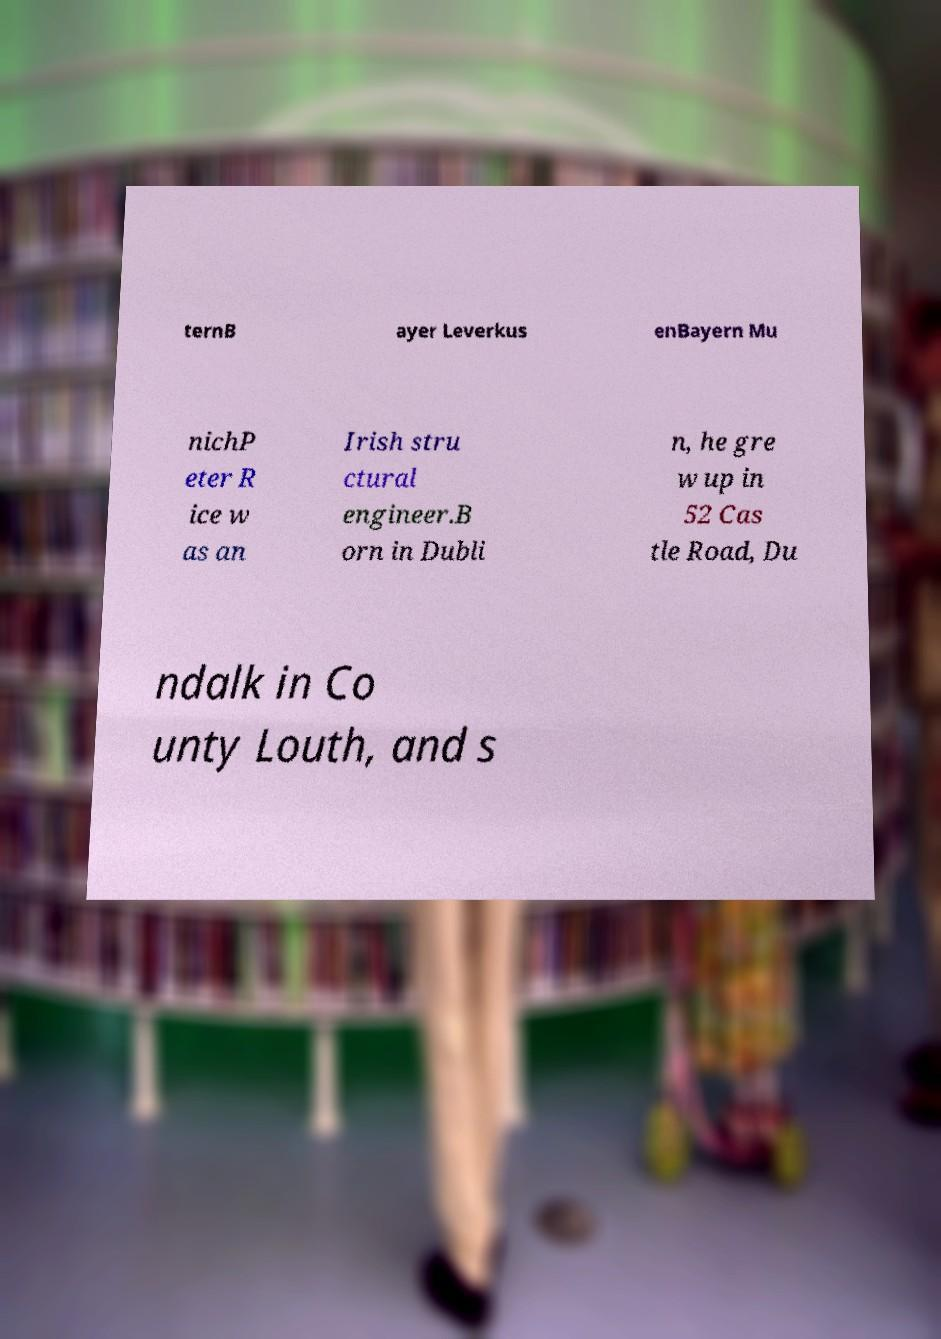I need the written content from this picture converted into text. Can you do that? ternB ayer Leverkus enBayern Mu nichP eter R ice w as an Irish stru ctural engineer.B orn in Dubli n, he gre w up in 52 Cas tle Road, Du ndalk in Co unty Louth, and s 